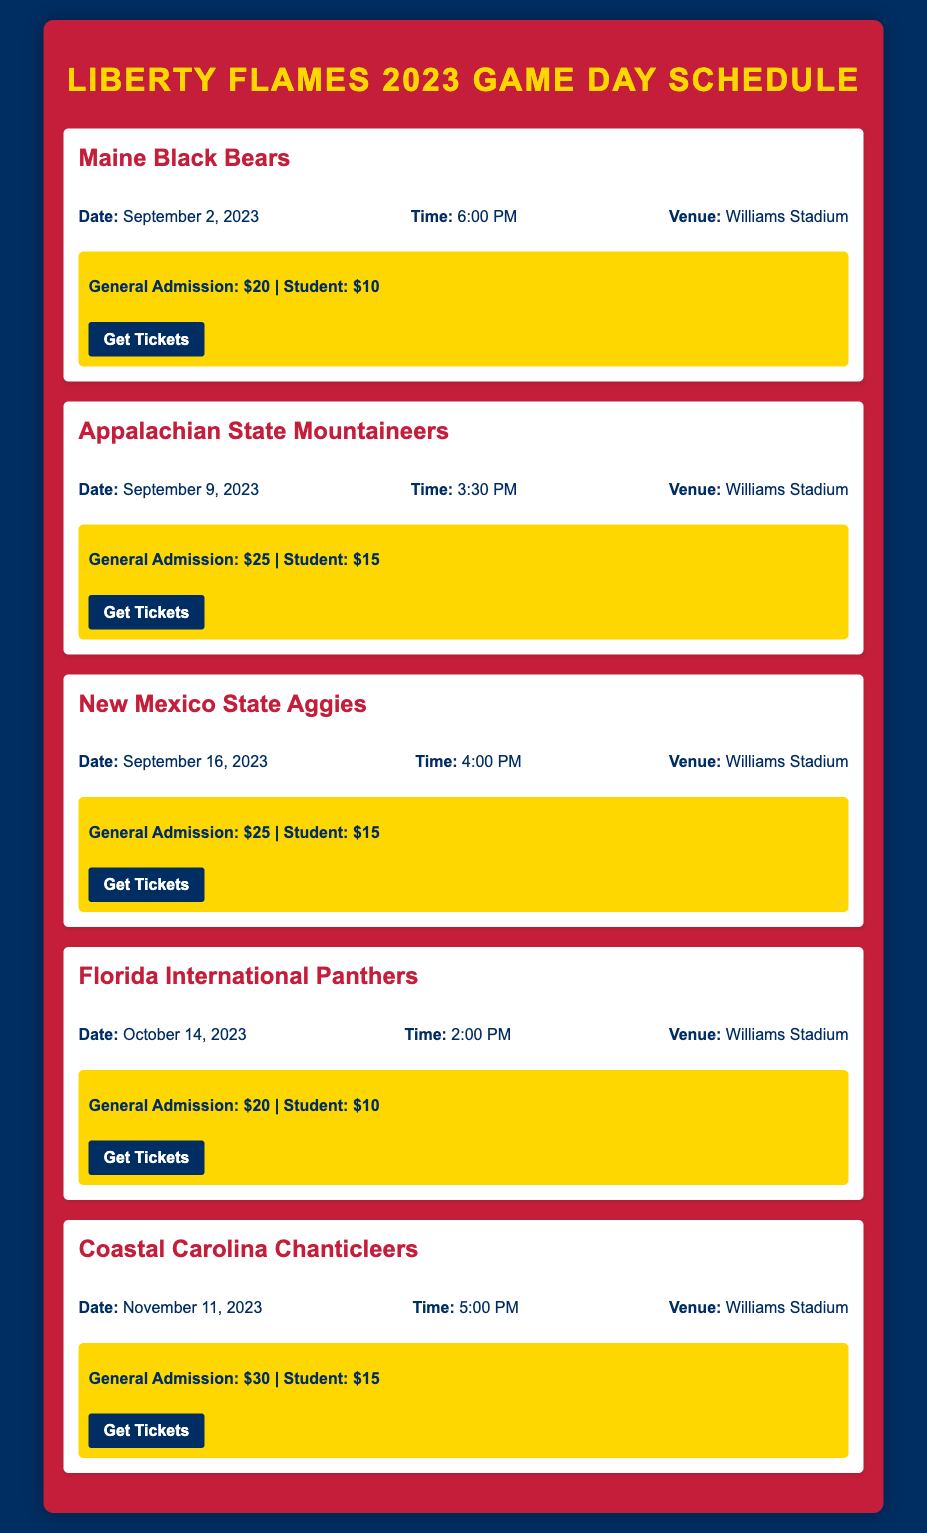What is the date of the game against the Maine Black Bears? The date of the game against the Maine Black Bears is clearly listed in the document, which is September 2, 2023.
Answer: September 2, 2023 What time does the game against Coastal Carolina start? The scheduled start time for the Coastal Carolina Chanticleers game is detailed as 5:00 PM in the document.
Answer: 5:00 PM How much is general admission for the game on October 14, 2023? General admission pricing for the Florida International Panthers game is specified as $20, according to the information displayed in the document.
Answer: $20 What venue will all home games be played at? The venue for all games listed is Williams Stadium, as mentioned for each game in the document.
Answer: Williams Stadium Which team plays on September 16, 2023? The team playing on September 16, 2023, is explicitly stated as the New Mexico State Aggies in the document.
Answer: New Mexico State Aggies What is the ticket price for students for the game against Appalachian State? The student ticket price for the Appalachian State Mountaineers game is $15, which is indicated in the ticket detail section of the document.
Answer: $15 How many home games are scheduled for the 2023 season? By counting the games listed in the document, there are a total of five home games scheduled for the season.
Answer: 5 What is the most expensive general admission ticket price listed? The maximum general admission ticket price found in the document is $30 for the game against Coastal Carolina.
Answer: $30 